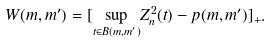Convert formula to latex. <formula><loc_0><loc_0><loc_500><loc_500>W ( m , m ^ { \prime } ) = [ \underset { t \in B ( m , m ^ { \prime } ) } { \sup } Z _ { n } ^ { 2 } ( t ) - p ( m , m ^ { \prime } ) ] _ { + } .</formula> 